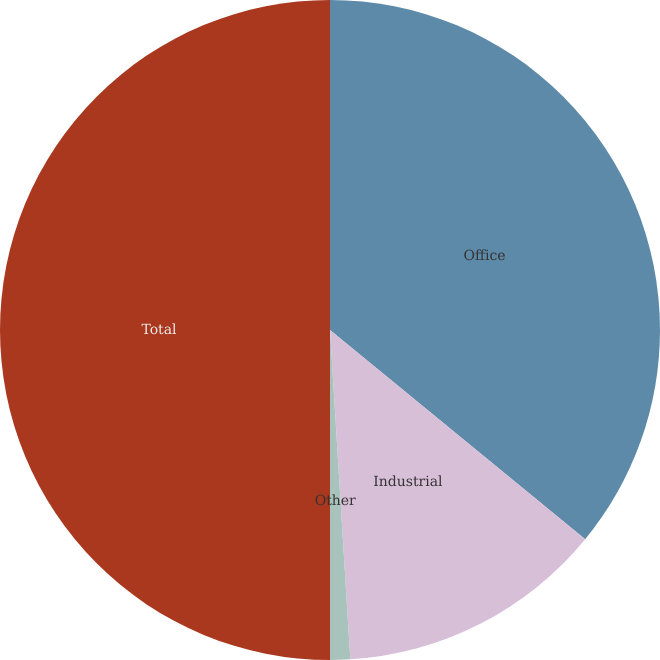<chart> <loc_0><loc_0><loc_500><loc_500><pie_chart><fcel>Office<fcel>Industrial<fcel>Other<fcel>Total<nl><fcel>35.93%<fcel>13.09%<fcel>0.98%<fcel>50.0%<nl></chart> 